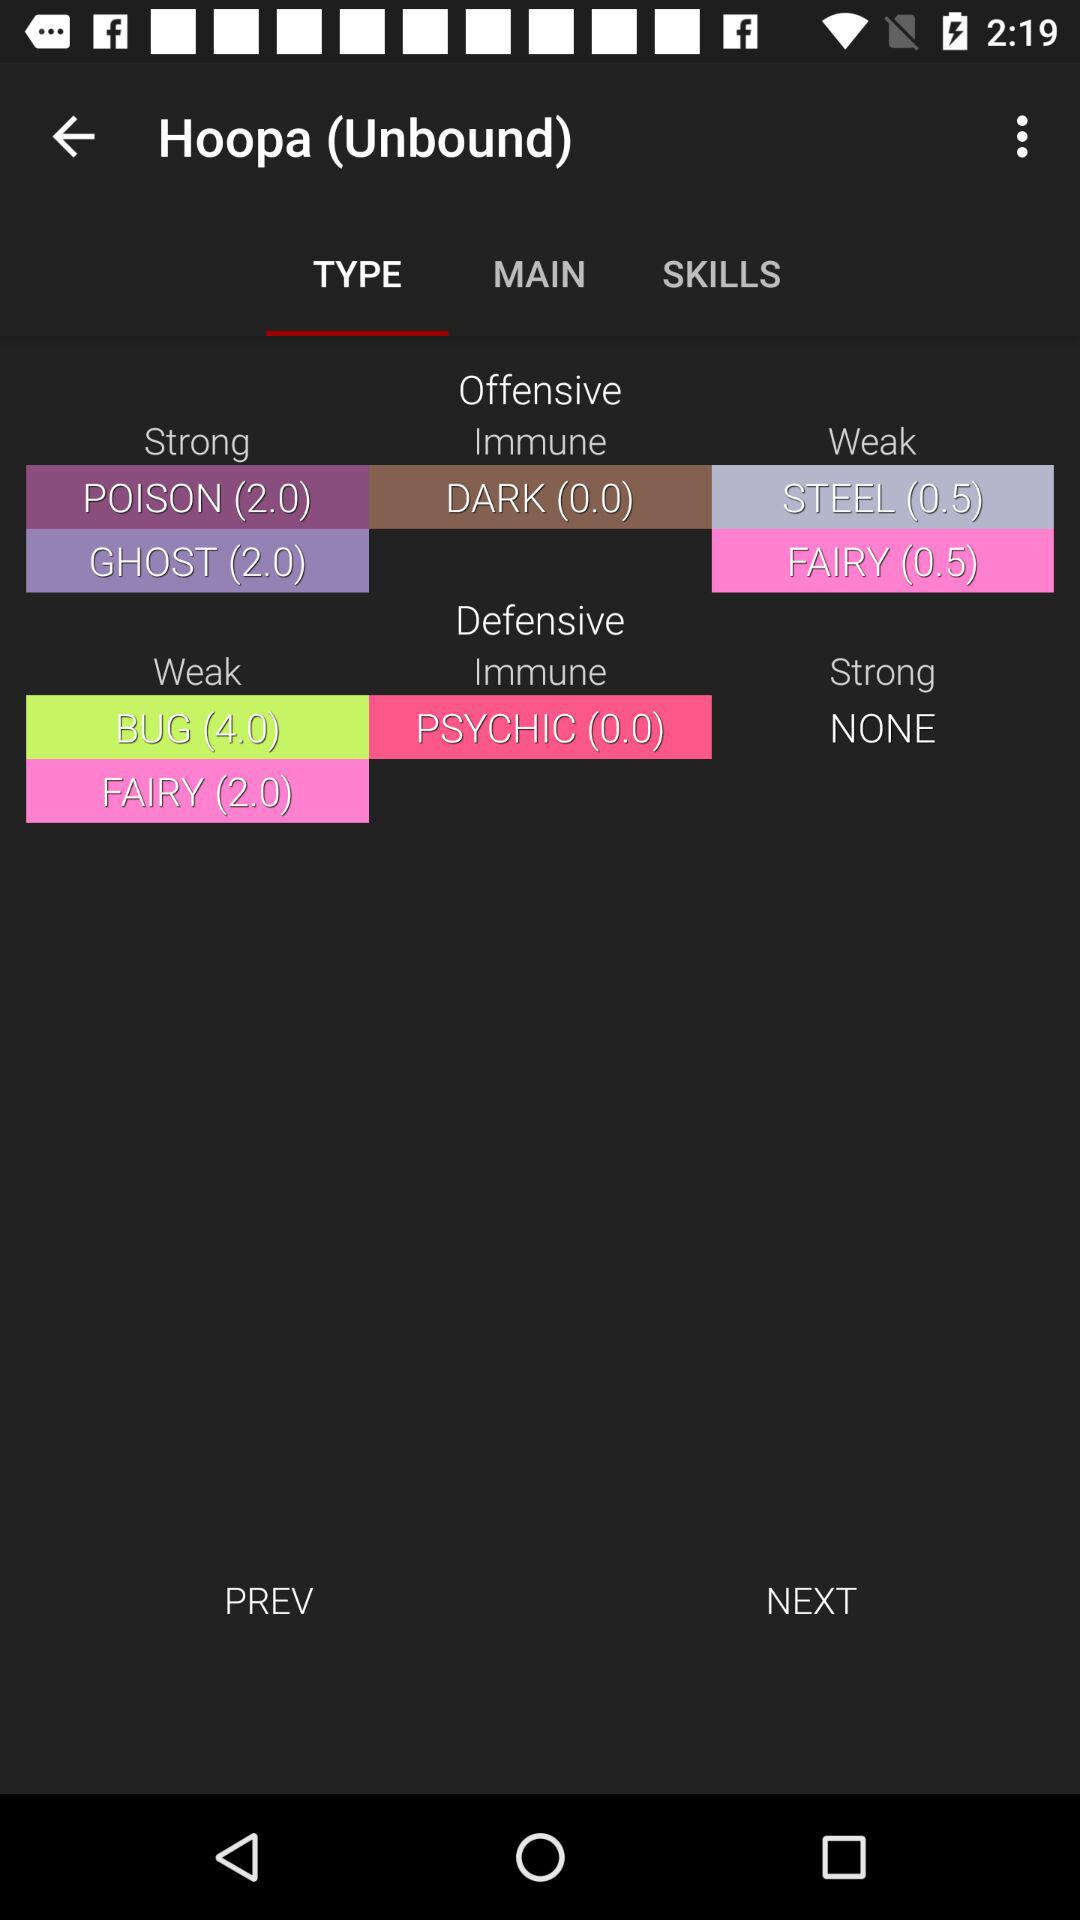What are the defensive points of "Hoopa (Unbound)" against "BUG" in the "Weak" category? The defensive points of "Hoopa (Unbound)" against "BUG" in the "Weak" category are 4.0. 